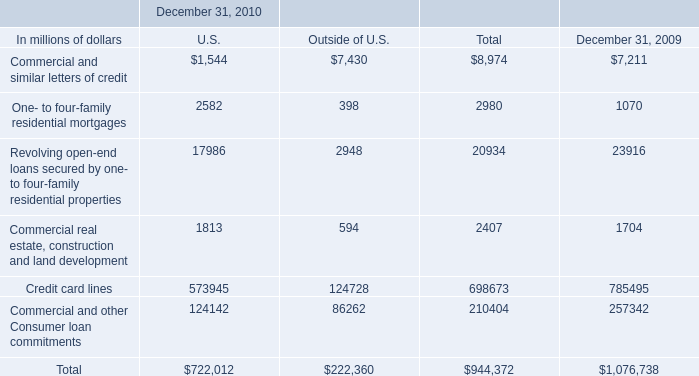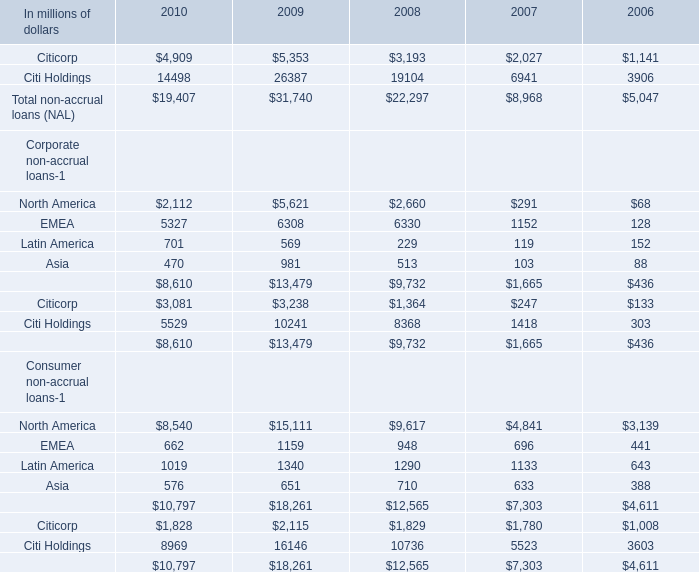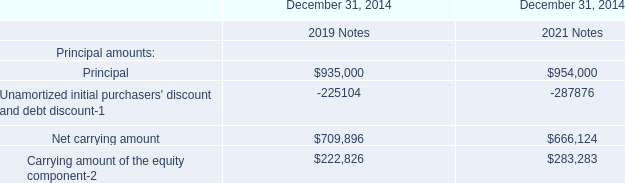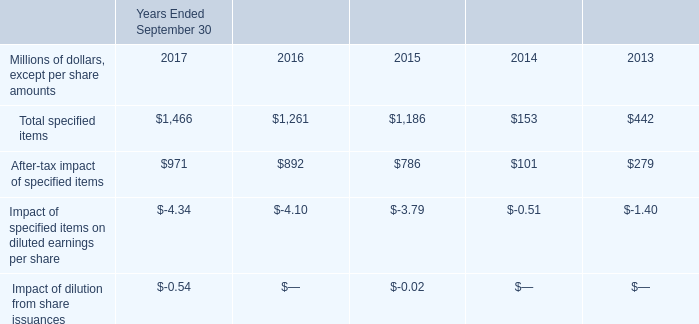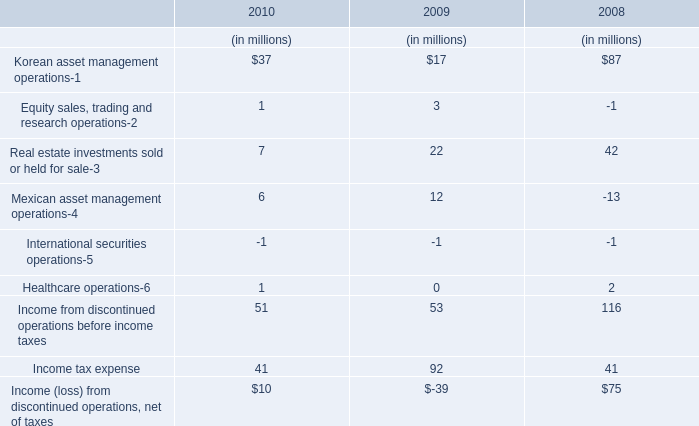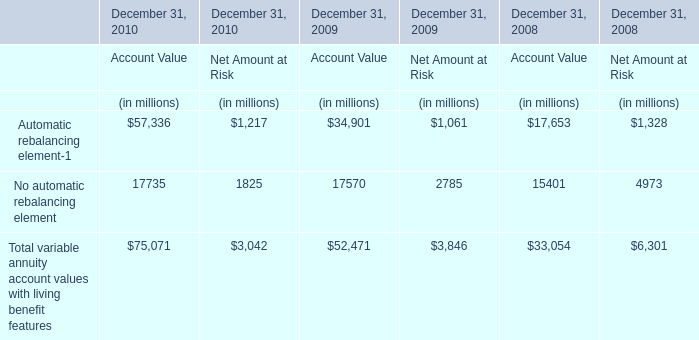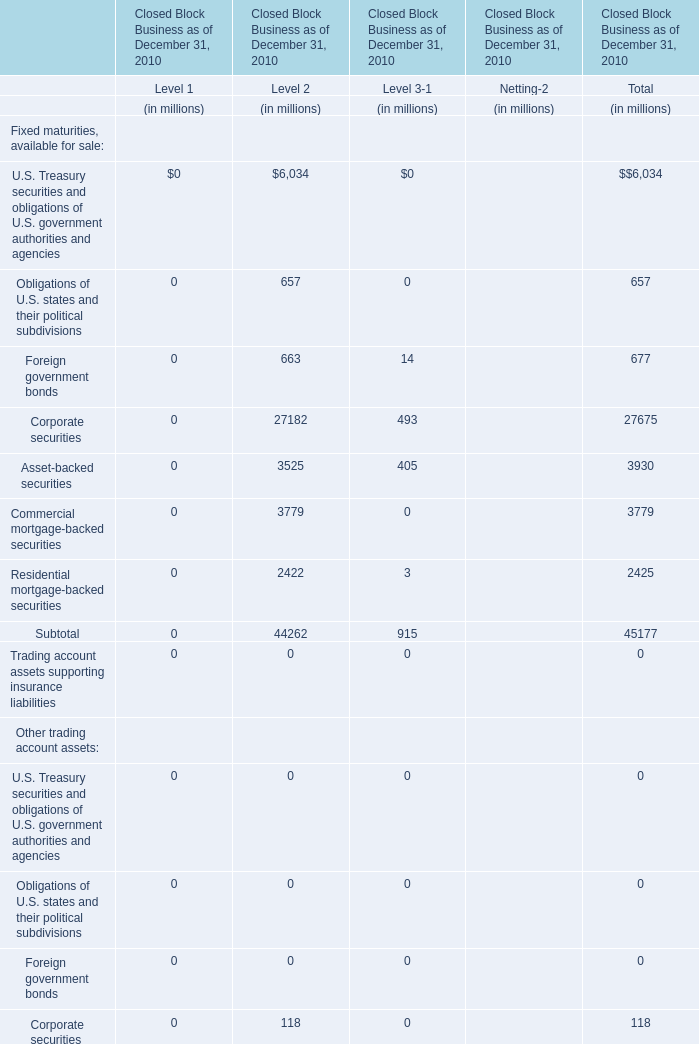What is the ratio of Asia in consumer non-accrual loans to the total in 2010? 
Computations: (576 / 10797)
Answer: 0.05335. 